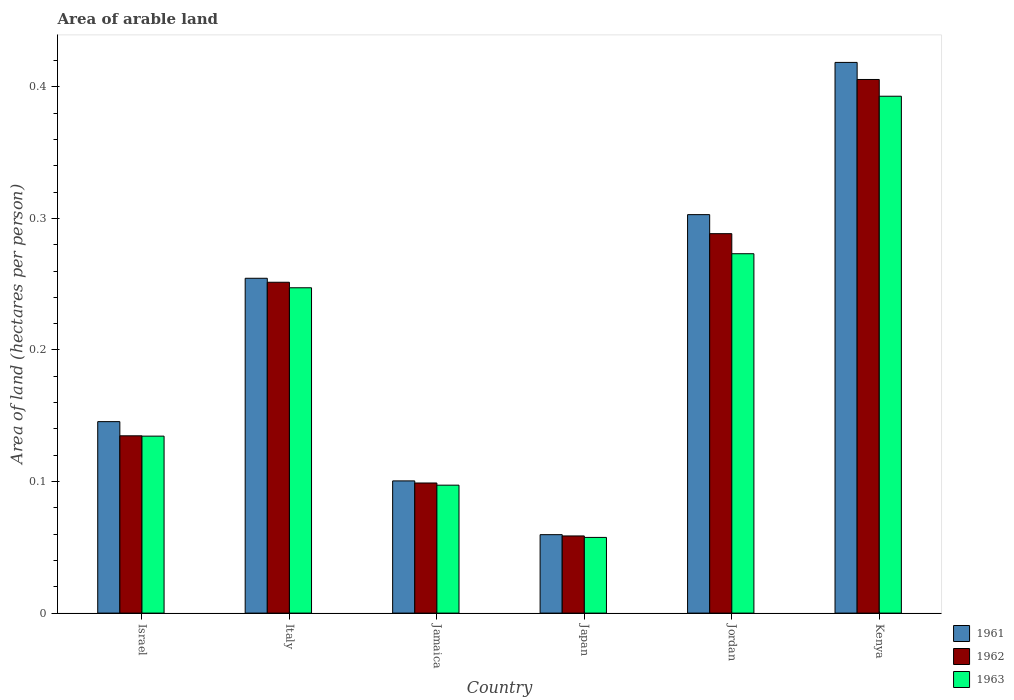Are the number of bars per tick equal to the number of legend labels?
Keep it short and to the point. Yes. Are the number of bars on each tick of the X-axis equal?
Provide a succinct answer. Yes. How many bars are there on the 6th tick from the right?
Provide a succinct answer. 3. What is the total arable land in 1963 in Japan?
Keep it short and to the point. 0.06. Across all countries, what is the maximum total arable land in 1962?
Offer a very short reply. 0.41. Across all countries, what is the minimum total arable land in 1961?
Give a very brief answer. 0.06. In which country was the total arable land in 1963 maximum?
Offer a terse response. Kenya. In which country was the total arable land in 1961 minimum?
Give a very brief answer. Japan. What is the total total arable land in 1962 in the graph?
Your answer should be very brief. 1.24. What is the difference between the total arable land in 1963 in Japan and that in Kenya?
Your answer should be very brief. -0.34. What is the difference between the total arable land in 1962 in Israel and the total arable land in 1961 in Jordan?
Offer a very short reply. -0.17. What is the average total arable land in 1963 per country?
Your answer should be compact. 0.2. What is the difference between the total arable land of/in 1962 and total arable land of/in 1961 in Israel?
Provide a succinct answer. -0.01. In how many countries, is the total arable land in 1962 greater than 0.04 hectares per person?
Ensure brevity in your answer.  6. What is the ratio of the total arable land in 1961 in Jamaica to that in Kenya?
Give a very brief answer. 0.24. Is the total arable land in 1963 in Jamaica less than that in Japan?
Provide a short and direct response. No. Is the difference between the total arable land in 1962 in Italy and Jamaica greater than the difference between the total arable land in 1961 in Italy and Jamaica?
Your answer should be compact. No. What is the difference between the highest and the second highest total arable land in 1963?
Provide a short and direct response. 0.12. What is the difference between the highest and the lowest total arable land in 1961?
Offer a very short reply. 0.36. In how many countries, is the total arable land in 1962 greater than the average total arable land in 1962 taken over all countries?
Provide a succinct answer. 3. What does the 1st bar from the left in Israel represents?
Give a very brief answer. 1961. What does the 2nd bar from the right in Jamaica represents?
Your response must be concise. 1962. Is it the case that in every country, the sum of the total arable land in 1963 and total arable land in 1961 is greater than the total arable land in 1962?
Provide a succinct answer. Yes. How many bars are there?
Offer a very short reply. 18. Are all the bars in the graph horizontal?
Give a very brief answer. No. Are the values on the major ticks of Y-axis written in scientific E-notation?
Provide a short and direct response. No. Does the graph contain any zero values?
Your answer should be very brief. No. How many legend labels are there?
Offer a very short reply. 3. What is the title of the graph?
Offer a very short reply. Area of arable land. Does "1990" appear as one of the legend labels in the graph?
Ensure brevity in your answer.  No. What is the label or title of the X-axis?
Your answer should be compact. Country. What is the label or title of the Y-axis?
Your answer should be compact. Area of land (hectares per person). What is the Area of land (hectares per person) of 1961 in Israel?
Keep it short and to the point. 0.15. What is the Area of land (hectares per person) in 1962 in Israel?
Give a very brief answer. 0.13. What is the Area of land (hectares per person) in 1963 in Israel?
Your response must be concise. 0.13. What is the Area of land (hectares per person) of 1961 in Italy?
Offer a very short reply. 0.25. What is the Area of land (hectares per person) in 1962 in Italy?
Your response must be concise. 0.25. What is the Area of land (hectares per person) of 1963 in Italy?
Keep it short and to the point. 0.25. What is the Area of land (hectares per person) in 1961 in Jamaica?
Your answer should be compact. 0.1. What is the Area of land (hectares per person) in 1962 in Jamaica?
Provide a short and direct response. 0.1. What is the Area of land (hectares per person) of 1963 in Jamaica?
Your response must be concise. 0.1. What is the Area of land (hectares per person) of 1961 in Japan?
Keep it short and to the point. 0.06. What is the Area of land (hectares per person) of 1962 in Japan?
Give a very brief answer. 0.06. What is the Area of land (hectares per person) in 1963 in Japan?
Your answer should be compact. 0.06. What is the Area of land (hectares per person) in 1961 in Jordan?
Your answer should be compact. 0.3. What is the Area of land (hectares per person) in 1962 in Jordan?
Your answer should be very brief. 0.29. What is the Area of land (hectares per person) in 1963 in Jordan?
Offer a very short reply. 0.27. What is the Area of land (hectares per person) of 1961 in Kenya?
Offer a very short reply. 0.42. What is the Area of land (hectares per person) in 1962 in Kenya?
Keep it short and to the point. 0.41. What is the Area of land (hectares per person) of 1963 in Kenya?
Your response must be concise. 0.39. Across all countries, what is the maximum Area of land (hectares per person) in 1961?
Keep it short and to the point. 0.42. Across all countries, what is the maximum Area of land (hectares per person) of 1962?
Offer a very short reply. 0.41. Across all countries, what is the maximum Area of land (hectares per person) of 1963?
Your answer should be compact. 0.39. Across all countries, what is the minimum Area of land (hectares per person) in 1961?
Provide a short and direct response. 0.06. Across all countries, what is the minimum Area of land (hectares per person) of 1962?
Ensure brevity in your answer.  0.06. Across all countries, what is the minimum Area of land (hectares per person) in 1963?
Your answer should be very brief. 0.06. What is the total Area of land (hectares per person) in 1961 in the graph?
Make the answer very short. 1.28. What is the total Area of land (hectares per person) of 1962 in the graph?
Keep it short and to the point. 1.24. What is the total Area of land (hectares per person) of 1963 in the graph?
Offer a terse response. 1.2. What is the difference between the Area of land (hectares per person) in 1961 in Israel and that in Italy?
Give a very brief answer. -0.11. What is the difference between the Area of land (hectares per person) in 1962 in Israel and that in Italy?
Give a very brief answer. -0.12. What is the difference between the Area of land (hectares per person) in 1963 in Israel and that in Italy?
Provide a succinct answer. -0.11. What is the difference between the Area of land (hectares per person) in 1961 in Israel and that in Jamaica?
Provide a succinct answer. 0.04. What is the difference between the Area of land (hectares per person) of 1962 in Israel and that in Jamaica?
Keep it short and to the point. 0.04. What is the difference between the Area of land (hectares per person) in 1963 in Israel and that in Jamaica?
Provide a short and direct response. 0.04. What is the difference between the Area of land (hectares per person) in 1961 in Israel and that in Japan?
Your answer should be compact. 0.09. What is the difference between the Area of land (hectares per person) of 1962 in Israel and that in Japan?
Give a very brief answer. 0.08. What is the difference between the Area of land (hectares per person) in 1963 in Israel and that in Japan?
Your answer should be very brief. 0.08. What is the difference between the Area of land (hectares per person) in 1961 in Israel and that in Jordan?
Offer a terse response. -0.16. What is the difference between the Area of land (hectares per person) of 1962 in Israel and that in Jordan?
Provide a short and direct response. -0.15. What is the difference between the Area of land (hectares per person) in 1963 in Israel and that in Jordan?
Your answer should be compact. -0.14. What is the difference between the Area of land (hectares per person) in 1961 in Israel and that in Kenya?
Keep it short and to the point. -0.27. What is the difference between the Area of land (hectares per person) in 1962 in Israel and that in Kenya?
Provide a short and direct response. -0.27. What is the difference between the Area of land (hectares per person) in 1963 in Israel and that in Kenya?
Provide a short and direct response. -0.26. What is the difference between the Area of land (hectares per person) in 1961 in Italy and that in Jamaica?
Give a very brief answer. 0.15. What is the difference between the Area of land (hectares per person) in 1962 in Italy and that in Jamaica?
Provide a succinct answer. 0.15. What is the difference between the Area of land (hectares per person) of 1963 in Italy and that in Jamaica?
Your answer should be compact. 0.15. What is the difference between the Area of land (hectares per person) of 1961 in Italy and that in Japan?
Offer a very short reply. 0.19. What is the difference between the Area of land (hectares per person) in 1962 in Italy and that in Japan?
Make the answer very short. 0.19. What is the difference between the Area of land (hectares per person) of 1963 in Italy and that in Japan?
Keep it short and to the point. 0.19. What is the difference between the Area of land (hectares per person) of 1961 in Italy and that in Jordan?
Provide a short and direct response. -0.05. What is the difference between the Area of land (hectares per person) of 1962 in Italy and that in Jordan?
Make the answer very short. -0.04. What is the difference between the Area of land (hectares per person) of 1963 in Italy and that in Jordan?
Your response must be concise. -0.03. What is the difference between the Area of land (hectares per person) of 1961 in Italy and that in Kenya?
Give a very brief answer. -0.16. What is the difference between the Area of land (hectares per person) of 1962 in Italy and that in Kenya?
Your answer should be compact. -0.15. What is the difference between the Area of land (hectares per person) of 1963 in Italy and that in Kenya?
Your answer should be very brief. -0.15. What is the difference between the Area of land (hectares per person) of 1961 in Jamaica and that in Japan?
Your answer should be compact. 0.04. What is the difference between the Area of land (hectares per person) in 1962 in Jamaica and that in Japan?
Make the answer very short. 0.04. What is the difference between the Area of land (hectares per person) in 1963 in Jamaica and that in Japan?
Ensure brevity in your answer.  0.04. What is the difference between the Area of land (hectares per person) in 1961 in Jamaica and that in Jordan?
Ensure brevity in your answer.  -0.2. What is the difference between the Area of land (hectares per person) in 1962 in Jamaica and that in Jordan?
Provide a short and direct response. -0.19. What is the difference between the Area of land (hectares per person) of 1963 in Jamaica and that in Jordan?
Provide a succinct answer. -0.18. What is the difference between the Area of land (hectares per person) in 1961 in Jamaica and that in Kenya?
Offer a terse response. -0.32. What is the difference between the Area of land (hectares per person) of 1962 in Jamaica and that in Kenya?
Make the answer very short. -0.31. What is the difference between the Area of land (hectares per person) in 1963 in Jamaica and that in Kenya?
Your response must be concise. -0.3. What is the difference between the Area of land (hectares per person) in 1961 in Japan and that in Jordan?
Ensure brevity in your answer.  -0.24. What is the difference between the Area of land (hectares per person) in 1962 in Japan and that in Jordan?
Make the answer very short. -0.23. What is the difference between the Area of land (hectares per person) in 1963 in Japan and that in Jordan?
Offer a terse response. -0.22. What is the difference between the Area of land (hectares per person) in 1961 in Japan and that in Kenya?
Your answer should be very brief. -0.36. What is the difference between the Area of land (hectares per person) of 1962 in Japan and that in Kenya?
Offer a terse response. -0.35. What is the difference between the Area of land (hectares per person) of 1963 in Japan and that in Kenya?
Give a very brief answer. -0.34. What is the difference between the Area of land (hectares per person) of 1961 in Jordan and that in Kenya?
Make the answer very short. -0.12. What is the difference between the Area of land (hectares per person) of 1962 in Jordan and that in Kenya?
Provide a short and direct response. -0.12. What is the difference between the Area of land (hectares per person) of 1963 in Jordan and that in Kenya?
Your response must be concise. -0.12. What is the difference between the Area of land (hectares per person) in 1961 in Israel and the Area of land (hectares per person) in 1962 in Italy?
Provide a short and direct response. -0.11. What is the difference between the Area of land (hectares per person) in 1961 in Israel and the Area of land (hectares per person) in 1963 in Italy?
Your answer should be very brief. -0.1. What is the difference between the Area of land (hectares per person) in 1962 in Israel and the Area of land (hectares per person) in 1963 in Italy?
Provide a succinct answer. -0.11. What is the difference between the Area of land (hectares per person) in 1961 in Israel and the Area of land (hectares per person) in 1962 in Jamaica?
Offer a terse response. 0.05. What is the difference between the Area of land (hectares per person) of 1961 in Israel and the Area of land (hectares per person) of 1963 in Jamaica?
Make the answer very short. 0.05. What is the difference between the Area of land (hectares per person) of 1962 in Israel and the Area of land (hectares per person) of 1963 in Jamaica?
Offer a terse response. 0.04. What is the difference between the Area of land (hectares per person) of 1961 in Israel and the Area of land (hectares per person) of 1962 in Japan?
Provide a short and direct response. 0.09. What is the difference between the Area of land (hectares per person) in 1961 in Israel and the Area of land (hectares per person) in 1963 in Japan?
Ensure brevity in your answer.  0.09. What is the difference between the Area of land (hectares per person) in 1962 in Israel and the Area of land (hectares per person) in 1963 in Japan?
Make the answer very short. 0.08. What is the difference between the Area of land (hectares per person) in 1961 in Israel and the Area of land (hectares per person) in 1962 in Jordan?
Your answer should be compact. -0.14. What is the difference between the Area of land (hectares per person) of 1961 in Israel and the Area of land (hectares per person) of 1963 in Jordan?
Make the answer very short. -0.13. What is the difference between the Area of land (hectares per person) in 1962 in Israel and the Area of land (hectares per person) in 1963 in Jordan?
Provide a succinct answer. -0.14. What is the difference between the Area of land (hectares per person) of 1961 in Israel and the Area of land (hectares per person) of 1962 in Kenya?
Offer a very short reply. -0.26. What is the difference between the Area of land (hectares per person) in 1961 in Israel and the Area of land (hectares per person) in 1963 in Kenya?
Give a very brief answer. -0.25. What is the difference between the Area of land (hectares per person) of 1962 in Israel and the Area of land (hectares per person) of 1963 in Kenya?
Provide a succinct answer. -0.26. What is the difference between the Area of land (hectares per person) of 1961 in Italy and the Area of land (hectares per person) of 1962 in Jamaica?
Your answer should be compact. 0.16. What is the difference between the Area of land (hectares per person) of 1961 in Italy and the Area of land (hectares per person) of 1963 in Jamaica?
Your response must be concise. 0.16. What is the difference between the Area of land (hectares per person) in 1962 in Italy and the Area of land (hectares per person) in 1963 in Jamaica?
Your response must be concise. 0.15. What is the difference between the Area of land (hectares per person) in 1961 in Italy and the Area of land (hectares per person) in 1962 in Japan?
Offer a terse response. 0.2. What is the difference between the Area of land (hectares per person) of 1961 in Italy and the Area of land (hectares per person) of 1963 in Japan?
Give a very brief answer. 0.2. What is the difference between the Area of land (hectares per person) of 1962 in Italy and the Area of land (hectares per person) of 1963 in Japan?
Offer a terse response. 0.19. What is the difference between the Area of land (hectares per person) of 1961 in Italy and the Area of land (hectares per person) of 1962 in Jordan?
Ensure brevity in your answer.  -0.03. What is the difference between the Area of land (hectares per person) of 1961 in Italy and the Area of land (hectares per person) of 1963 in Jordan?
Ensure brevity in your answer.  -0.02. What is the difference between the Area of land (hectares per person) of 1962 in Italy and the Area of land (hectares per person) of 1963 in Jordan?
Make the answer very short. -0.02. What is the difference between the Area of land (hectares per person) of 1961 in Italy and the Area of land (hectares per person) of 1962 in Kenya?
Offer a terse response. -0.15. What is the difference between the Area of land (hectares per person) of 1961 in Italy and the Area of land (hectares per person) of 1963 in Kenya?
Offer a very short reply. -0.14. What is the difference between the Area of land (hectares per person) in 1962 in Italy and the Area of land (hectares per person) in 1963 in Kenya?
Make the answer very short. -0.14. What is the difference between the Area of land (hectares per person) of 1961 in Jamaica and the Area of land (hectares per person) of 1962 in Japan?
Your response must be concise. 0.04. What is the difference between the Area of land (hectares per person) in 1961 in Jamaica and the Area of land (hectares per person) in 1963 in Japan?
Ensure brevity in your answer.  0.04. What is the difference between the Area of land (hectares per person) of 1962 in Jamaica and the Area of land (hectares per person) of 1963 in Japan?
Offer a very short reply. 0.04. What is the difference between the Area of land (hectares per person) of 1961 in Jamaica and the Area of land (hectares per person) of 1962 in Jordan?
Offer a very short reply. -0.19. What is the difference between the Area of land (hectares per person) of 1961 in Jamaica and the Area of land (hectares per person) of 1963 in Jordan?
Ensure brevity in your answer.  -0.17. What is the difference between the Area of land (hectares per person) of 1962 in Jamaica and the Area of land (hectares per person) of 1963 in Jordan?
Offer a terse response. -0.17. What is the difference between the Area of land (hectares per person) of 1961 in Jamaica and the Area of land (hectares per person) of 1962 in Kenya?
Keep it short and to the point. -0.31. What is the difference between the Area of land (hectares per person) in 1961 in Jamaica and the Area of land (hectares per person) in 1963 in Kenya?
Your answer should be compact. -0.29. What is the difference between the Area of land (hectares per person) in 1962 in Jamaica and the Area of land (hectares per person) in 1963 in Kenya?
Provide a short and direct response. -0.29. What is the difference between the Area of land (hectares per person) of 1961 in Japan and the Area of land (hectares per person) of 1962 in Jordan?
Your response must be concise. -0.23. What is the difference between the Area of land (hectares per person) of 1961 in Japan and the Area of land (hectares per person) of 1963 in Jordan?
Keep it short and to the point. -0.21. What is the difference between the Area of land (hectares per person) in 1962 in Japan and the Area of land (hectares per person) in 1963 in Jordan?
Your answer should be very brief. -0.21. What is the difference between the Area of land (hectares per person) in 1961 in Japan and the Area of land (hectares per person) in 1962 in Kenya?
Your response must be concise. -0.35. What is the difference between the Area of land (hectares per person) in 1962 in Japan and the Area of land (hectares per person) in 1963 in Kenya?
Provide a short and direct response. -0.33. What is the difference between the Area of land (hectares per person) of 1961 in Jordan and the Area of land (hectares per person) of 1962 in Kenya?
Give a very brief answer. -0.1. What is the difference between the Area of land (hectares per person) of 1961 in Jordan and the Area of land (hectares per person) of 1963 in Kenya?
Ensure brevity in your answer.  -0.09. What is the difference between the Area of land (hectares per person) of 1962 in Jordan and the Area of land (hectares per person) of 1963 in Kenya?
Offer a very short reply. -0.1. What is the average Area of land (hectares per person) of 1961 per country?
Offer a terse response. 0.21. What is the average Area of land (hectares per person) in 1962 per country?
Your answer should be compact. 0.21. What is the average Area of land (hectares per person) in 1963 per country?
Provide a succinct answer. 0.2. What is the difference between the Area of land (hectares per person) in 1961 and Area of land (hectares per person) in 1962 in Israel?
Your answer should be very brief. 0.01. What is the difference between the Area of land (hectares per person) in 1961 and Area of land (hectares per person) in 1963 in Israel?
Provide a short and direct response. 0.01. What is the difference between the Area of land (hectares per person) of 1962 and Area of land (hectares per person) of 1963 in Israel?
Keep it short and to the point. 0. What is the difference between the Area of land (hectares per person) in 1961 and Area of land (hectares per person) in 1962 in Italy?
Your answer should be very brief. 0. What is the difference between the Area of land (hectares per person) in 1961 and Area of land (hectares per person) in 1963 in Italy?
Offer a very short reply. 0.01. What is the difference between the Area of land (hectares per person) in 1962 and Area of land (hectares per person) in 1963 in Italy?
Ensure brevity in your answer.  0. What is the difference between the Area of land (hectares per person) of 1961 and Area of land (hectares per person) of 1962 in Jamaica?
Your answer should be very brief. 0. What is the difference between the Area of land (hectares per person) of 1961 and Area of land (hectares per person) of 1963 in Jamaica?
Your response must be concise. 0. What is the difference between the Area of land (hectares per person) in 1962 and Area of land (hectares per person) in 1963 in Jamaica?
Ensure brevity in your answer.  0. What is the difference between the Area of land (hectares per person) in 1961 and Area of land (hectares per person) in 1963 in Japan?
Your response must be concise. 0. What is the difference between the Area of land (hectares per person) in 1962 and Area of land (hectares per person) in 1963 in Japan?
Offer a terse response. 0. What is the difference between the Area of land (hectares per person) in 1961 and Area of land (hectares per person) in 1962 in Jordan?
Offer a terse response. 0.01. What is the difference between the Area of land (hectares per person) in 1961 and Area of land (hectares per person) in 1963 in Jordan?
Keep it short and to the point. 0.03. What is the difference between the Area of land (hectares per person) in 1962 and Area of land (hectares per person) in 1963 in Jordan?
Provide a short and direct response. 0.02. What is the difference between the Area of land (hectares per person) in 1961 and Area of land (hectares per person) in 1962 in Kenya?
Offer a very short reply. 0.01. What is the difference between the Area of land (hectares per person) of 1961 and Area of land (hectares per person) of 1963 in Kenya?
Your response must be concise. 0.03. What is the difference between the Area of land (hectares per person) in 1962 and Area of land (hectares per person) in 1963 in Kenya?
Your answer should be very brief. 0.01. What is the ratio of the Area of land (hectares per person) in 1961 in Israel to that in Italy?
Keep it short and to the point. 0.57. What is the ratio of the Area of land (hectares per person) of 1962 in Israel to that in Italy?
Ensure brevity in your answer.  0.54. What is the ratio of the Area of land (hectares per person) in 1963 in Israel to that in Italy?
Give a very brief answer. 0.54. What is the ratio of the Area of land (hectares per person) of 1961 in Israel to that in Jamaica?
Ensure brevity in your answer.  1.45. What is the ratio of the Area of land (hectares per person) of 1962 in Israel to that in Jamaica?
Give a very brief answer. 1.36. What is the ratio of the Area of land (hectares per person) of 1963 in Israel to that in Jamaica?
Your response must be concise. 1.38. What is the ratio of the Area of land (hectares per person) in 1961 in Israel to that in Japan?
Make the answer very short. 2.44. What is the ratio of the Area of land (hectares per person) in 1962 in Israel to that in Japan?
Keep it short and to the point. 2.3. What is the ratio of the Area of land (hectares per person) of 1963 in Israel to that in Japan?
Your answer should be compact. 2.34. What is the ratio of the Area of land (hectares per person) in 1961 in Israel to that in Jordan?
Give a very brief answer. 0.48. What is the ratio of the Area of land (hectares per person) of 1962 in Israel to that in Jordan?
Offer a terse response. 0.47. What is the ratio of the Area of land (hectares per person) of 1963 in Israel to that in Jordan?
Keep it short and to the point. 0.49. What is the ratio of the Area of land (hectares per person) in 1961 in Israel to that in Kenya?
Keep it short and to the point. 0.35. What is the ratio of the Area of land (hectares per person) of 1962 in Israel to that in Kenya?
Make the answer very short. 0.33. What is the ratio of the Area of land (hectares per person) of 1963 in Israel to that in Kenya?
Keep it short and to the point. 0.34. What is the ratio of the Area of land (hectares per person) of 1961 in Italy to that in Jamaica?
Offer a very short reply. 2.53. What is the ratio of the Area of land (hectares per person) of 1962 in Italy to that in Jamaica?
Make the answer very short. 2.54. What is the ratio of the Area of land (hectares per person) of 1963 in Italy to that in Jamaica?
Provide a succinct answer. 2.54. What is the ratio of the Area of land (hectares per person) in 1961 in Italy to that in Japan?
Keep it short and to the point. 4.27. What is the ratio of the Area of land (hectares per person) of 1962 in Italy to that in Japan?
Your answer should be compact. 4.29. What is the ratio of the Area of land (hectares per person) in 1963 in Italy to that in Japan?
Give a very brief answer. 4.3. What is the ratio of the Area of land (hectares per person) in 1961 in Italy to that in Jordan?
Give a very brief answer. 0.84. What is the ratio of the Area of land (hectares per person) in 1962 in Italy to that in Jordan?
Provide a short and direct response. 0.87. What is the ratio of the Area of land (hectares per person) of 1963 in Italy to that in Jordan?
Offer a very short reply. 0.91. What is the ratio of the Area of land (hectares per person) of 1961 in Italy to that in Kenya?
Provide a short and direct response. 0.61. What is the ratio of the Area of land (hectares per person) of 1962 in Italy to that in Kenya?
Your response must be concise. 0.62. What is the ratio of the Area of land (hectares per person) of 1963 in Italy to that in Kenya?
Keep it short and to the point. 0.63. What is the ratio of the Area of land (hectares per person) in 1961 in Jamaica to that in Japan?
Your answer should be compact. 1.69. What is the ratio of the Area of land (hectares per person) in 1962 in Jamaica to that in Japan?
Your answer should be compact. 1.69. What is the ratio of the Area of land (hectares per person) in 1963 in Jamaica to that in Japan?
Keep it short and to the point. 1.69. What is the ratio of the Area of land (hectares per person) of 1961 in Jamaica to that in Jordan?
Offer a terse response. 0.33. What is the ratio of the Area of land (hectares per person) in 1962 in Jamaica to that in Jordan?
Your answer should be compact. 0.34. What is the ratio of the Area of land (hectares per person) in 1963 in Jamaica to that in Jordan?
Your response must be concise. 0.36. What is the ratio of the Area of land (hectares per person) in 1961 in Jamaica to that in Kenya?
Keep it short and to the point. 0.24. What is the ratio of the Area of land (hectares per person) of 1962 in Jamaica to that in Kenya?
Give a very brief answer. 0.24. What is the ratio of the Area of land (hectares per person) of 1963 in Jamaica to that in Kenya?
Offer a very short reply. 0.25. What is the ratio of the Area of land (hectares per person) of 1961 in Japan to that in Jordan?
Offer a very short reply. 0.2. What is the ratio of the Area of land (hectares per person) in 1962 in Japan to that in Jordan?
Keep it short and to the point. 0.2. What is the ratio of the Area of land (hectares per person) of 1963 in Japan to that in Jordan?
Offer a terse response. 0.21. What is the ratio of the Area of land (hectares per person) of 1961 in Japan to that in Kenya?
Offer a very short reply. 0.14. What is the ratio of the Area of land (hectares per person) in 1962 in Japan to that in Kenya?
Your answer should be very brief. 0.14. What is the ratio of the Area of land (hectares per person) of 1963 in Japan to that in Kenya?
Offer a terse response. 0.15. What is the ratio of the Area of land (hectares per person) of 1961 in Jordan to that in Kenya?
Make the answer very short. 0.72. What is the ratio of the Area of land (hectares per person) in 1962 in Jordan to that in Kenya?
Ensure brevity in your answer.  0.71. What is the ratio of the Area of land (hectares per person) in 1963 in Jordan to that in Kenya?
Offer a very short reply. 0.7. What is the difference between the highest and the second highest Area of land (hectares per person) in 1961?
Ensure brevity in your answer.  0.12. What is the difference between the highest and the second highest Area of land (hectares per person) in 1962?
Your answer should be compact. 0.12. What is the difference between the highest and the second highest Area of land (hectares per person) of 1963?
Make the answer very short. 0.12. What is the difference between the highest and the lowest Area of land (hectares per person) of 1961?
Your response must be concise. 0.36. What is the difference between the highest and the lowest Area of land (hectares per person) of 1962?
Provide a short and direct response. 0.35. What is the difference between the highest and the lowest Area of land (hectares per person) of 1963?
Your response must be concise. 0.34. 